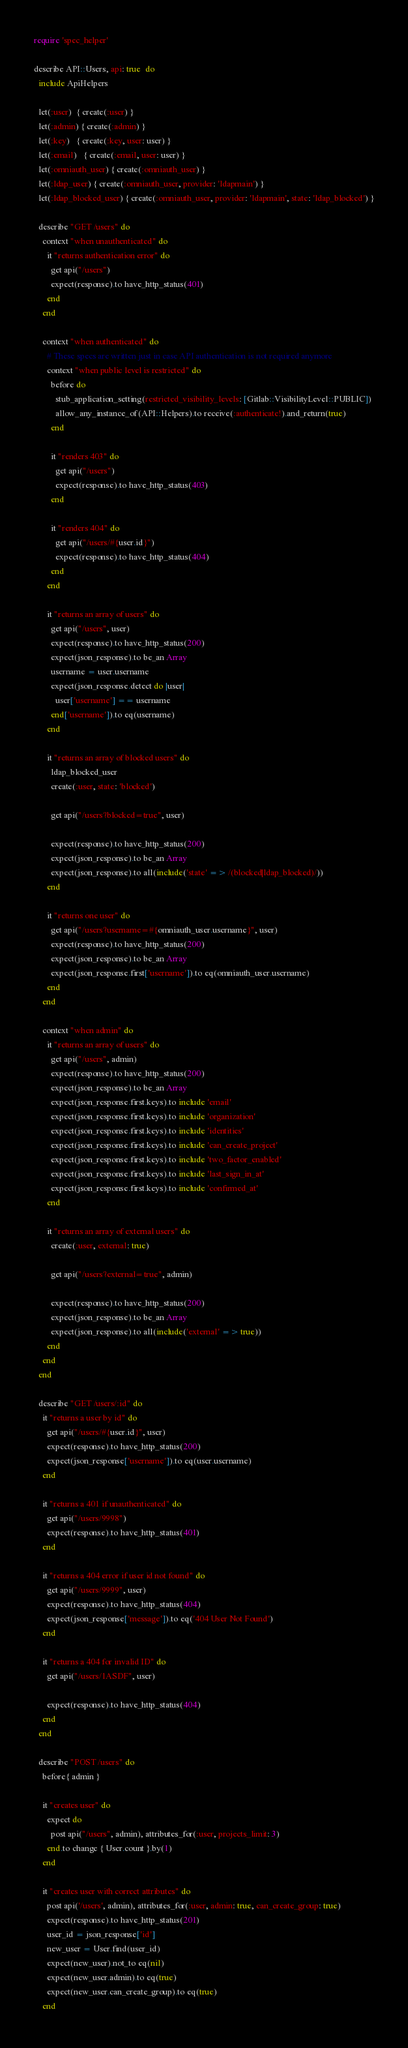<code> <loc_0><loc_0><loc_500><loc_500><_Ruby_>require 'spec_helper'

describe API::Users, api: true  do
  include ApiHelpers

  let(:user)  { create(:user) }
  let(:admin) { create(:admin) }
  let(:key)   { create(:key, user: user) }
  let(:email)   { create(:email, user: user) }
  let(:omniauth_user) { create(:omniauth_user) }
  let(:ldap_user) { create(:omniauth_user, provider: 'ldapmain') }
  let(:ldap_blocked_user) { create(:omniauth_user, provider: 'ldapmain', state: 'ldap_blocked') }

  describe "GET /users" do
    context "when unauthenticated" do
      it "returns authentication error" do
        get api("/users")
        expect(response).to have_http_status(401)
      end
    end

    context "when authenticated" do
      # These specs are written just in case API authentication is not required anymore
      context "when public level is restricted" do
        before do
          stub_application_setting(restricted_visibility_levels: [Gitlab::VisibilityLevel::PUBLIC])
          allow_any_instance_of(API::Helpers).to receive(:authenticate!).and_return(true)
        end

        it "renders 403" do
          get api("/users")
          expect(response).to have_http_status(403)
        end

        it "renders 404" do
          get api("/users/#{user.id}")
          expect(response).to have_http_status(404)
        end
      end

      it "returns an array of users" do
        get api("/users", user)
        expect(response).to have_http_status(200)
        expect(json_response).to be_an Array
        username = user.username
        expect(json_response.detect do |user|
          user['username'] == username
        end['username']).to eq(username)
      end

      it "returns an array of blocked users" do
        ldap_blocked_user
        create(:user, state: 'blocked')

        get api("/users?blocked=true", user)

        expect(response).to have_http_status(200)
        expect(json_response).to be_an Array
        expect(json_response).to all(include('state' => /(blocked|ldap_blocked)/))
      end

      it "returns one user" do
        get api("/users?username=#{omniauth_user.username}", user)
        expect(response).to have_http_status(200)
        expect(json_response).to be_an Array
        expect(json_response.first['username']).to eq(omniauth_user.username)
      end
    end

    context "when admin" do
      it "returns an array of users" do
        get api("/users", admin)
        expect(response).to have_http_status(200)
        expect(json_response).to be_an Array
        expect(json_response.first.keys).to include 'email'
        expect(json_response.first.keys).to include 'organization'
        expect(json_response.first.keys).to include 'identities'
        expect(json_response.first.keys).to include 'can_create_project'
        expect(json_response.first.keys).to include 'two_factor_enabled'
        expect(json_response.first.keys).to include 'last_sign_in_at'
        expect(json_response.first.keys).to include 'confirmed_at'
      end

      it "returns an array of external users" do
        create(:user, external: true)

        get api("/users?external=true", admin)

        expect(response).to have_http_status(200)
        expect(json_response).to be_an Array
        expect(json_response).to all(include('external' => true))
      end
    end
  end

  describe "GET /users/:id" do
    it "returns a user by id" do
      get api("/users/#{user.id}", user)
      expect(response).to have_http_status(200)
      expect(json_response['username']).to eq(user.username)
    end

    it "returns a 401 if unauthenticated" do
      get api("/users/9998")
      expect(response).to have_http_status(401)
    end

    it "returns a 404 error if user id not found" do
      get api("/users/9999", user)
      expect(response).to have_http_status(404)
      expect(json_response['message']).to eq('404 User Not Found')
    end

    it "returns a 404 for invalid ID" do
      get api("/users/1ASDF", user)

      expect(response).to have_http_status(404)
    end
  end

  describe "POST /users" do
    before{ admin }

    it "creates user" do
      expect do
        post api("/users", admin), attributes_for(:user, projects_limit: 3)
      end.to change { User.count }.by(1)
    end

    it "creates user with correct attributes" do
      post api('/users', admin), attributes_for(:user, admin: true, can_create_group: true)
      expect(response).to have_http_status(201)
      user_id = json_response['id']
      new_user = User.find(user_id)
      expect(new_user).not_to eq(nil)
      expect(new_user.admin).to eq(true)
      expect(new_user.can_create_group).to eq(true)
    end
</code> 